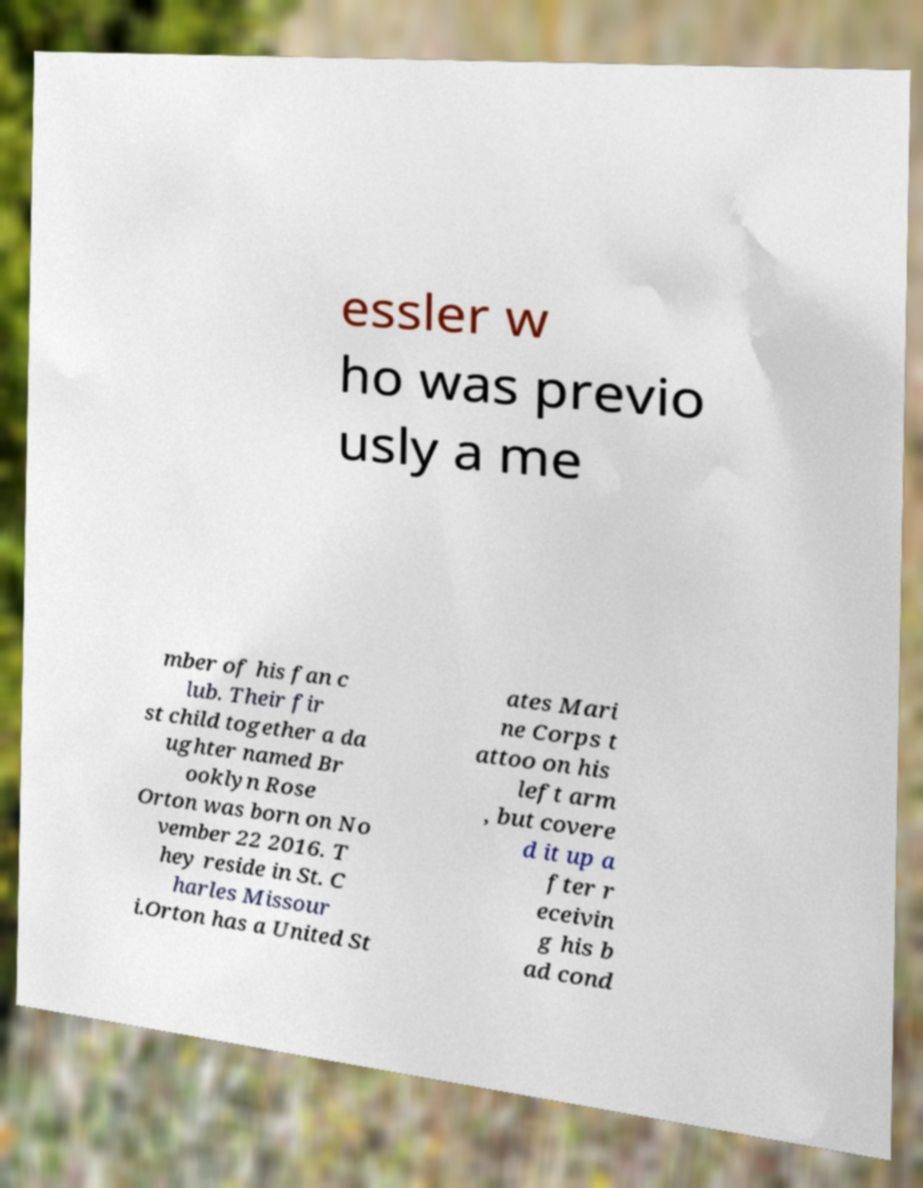Please read and relay the text visible in this image. What does it say? essler w ho was previo usly a me mber of his fan c lub. Their fir st child together a da ughter named Br ooklyn Rose Orton was born on No vember 22 2016. T hey reside in St. C harles Missour i.Orton has a United St ates Mari ne Corps t attoo on his left arm , but covere d it up a fter r eceivin g his b ad cond 